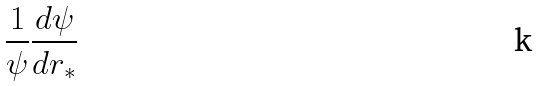<formula> <loc_0><loc_0><loc_500><loc_500>\frac { 1 } { \psi } \frac { d \psi } { d r _ { * } }</formula> 